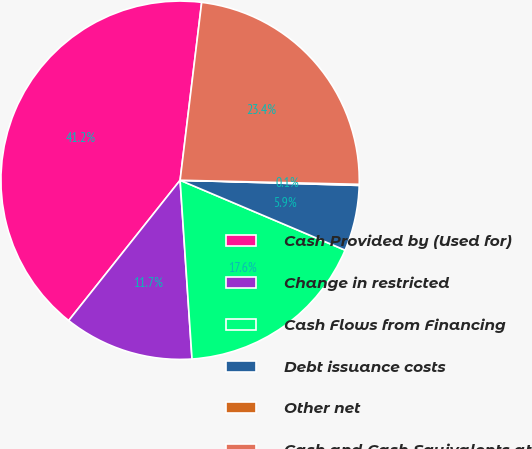Convert chart. <chart><loc_0><loc_0><loc_500><loc_500><pie_chart><fcel>Cash Provided by (Used for)<fcel>Change in restricted<fcel>Cash Flows from Financing<fcel>Debt issuance costs<fcel>Other net<fcel>Cash and Cash Equivalents at<nl><fcel>41.24%<fcel>11.74%<fcel>17.56%<fcel>5.92%<fcel>0.1%<fcel>23.44%<nl></chart> 